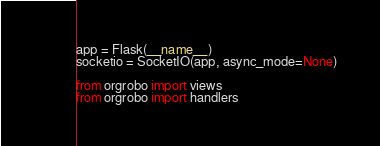<code> <loc_0><loc_0><loc_500><loc_500><_Python_>
app = Flask(__name__)
socketio = SocketIO(app, async_mode=None)

from orgrobo import views
from orgrobo import handlers
</code> 